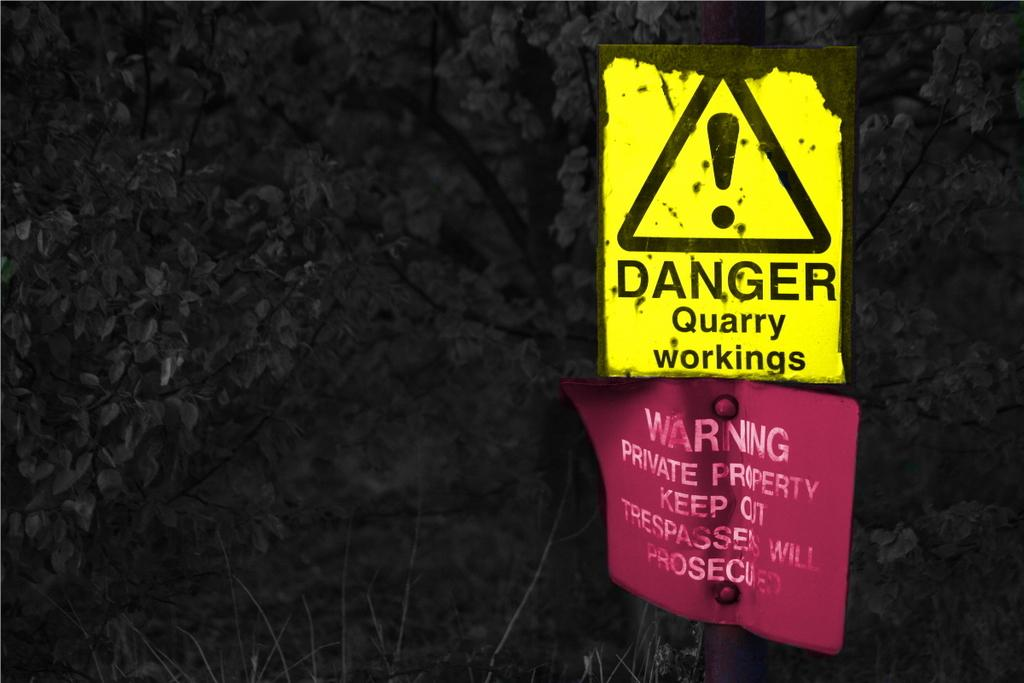What is attached to the pole in the image? There are yellow and pink caution boards attached to the pole in the image. What type of surface is at the bottom of the image? The bottom of the image contains grass. What can be seen in the background of the image? Trees are visible in the background of the image. What is the color of the background in the image? The background of the image is dark. What type of leather is the spoon made of in the image? There is no spoon or leather present in the image. 